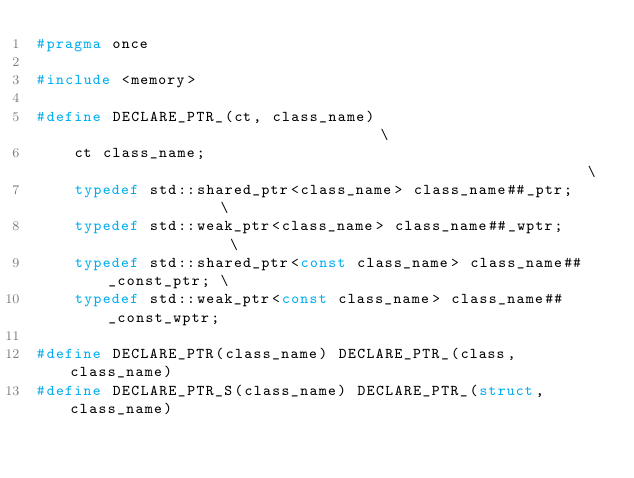Convert code to text. <code><loc_0><loc_0><loc_500><loc_500><_C_>#pragma once

#include <memory>

#define DECLARE_PTR_(ct, class_name)                                  \
    ct class_name;                                                    \
    typedef std::shared_ptr<class_name> class_name##_ptr;             \
    typedef std::weak_ptr<class_name> class_name##_wptr;              \
    typedef std::shared_ptr<const class_name> class_name##_const_ptr; \
    typedef std::weak_ptr<const class_name> class_name##_const_wptr;

#define DECLARE_PTR(class_name) DECLARE_PTR_(class, class_name)
#define DECLARE_PTR_S(class_name) DECLARE_PTR_(struct, class_name)
</code> 